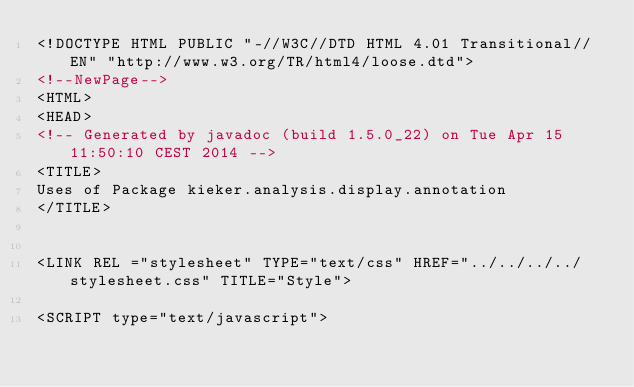<code> <loc_0><loc_0><loc_500><loc_500><_HTML_><!DOCTYPE HTML PUBLIC "-//W3C//DTD HTML 4.01 Transitional//EN" "http://www.w3.org/TR/html4/loose.dtd">
<!--NewPage-->
<HTML>
<HEAD>
<!-- Generated by javadoc (build 1.5.0_22) on Tue Apr 15 11:50:10 CEST 2014 -->
<TITLE>
Uses of Package kieker.analysis.display.annotation
</TITLE>


<LINK REL ="stylesheet" TYPE="text/css" HREF="../../../../stylesheet.css" TITLE="Style">

<SCRIPT type="text/javascript"></code> 